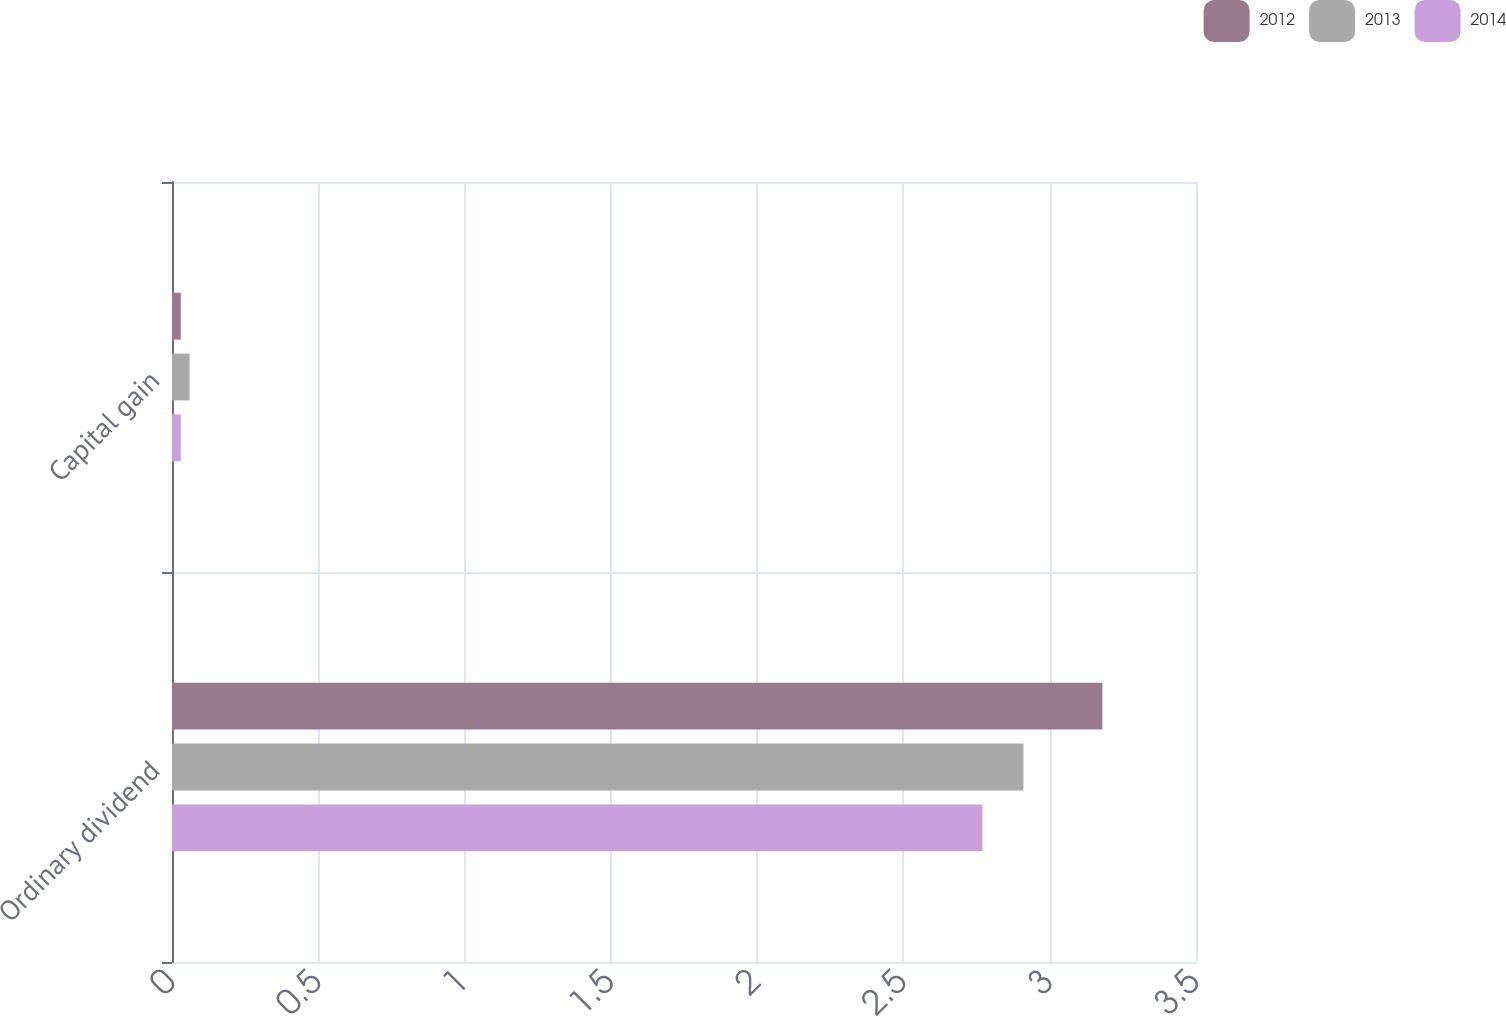<chart> <loc_0><loc_0><loc_500><loc_500><stacked_bar_chart><ecel><fcel>Ordinary dividend<fcel>Capital gain<nl><fcel>2012<fcel>3.18<fcel>0.03<nl><fcel>2013<fcel>2.91<fcel>0.06<nl><fcel>2014<fcel>2.77<fcel>0.03<nl></chart> 